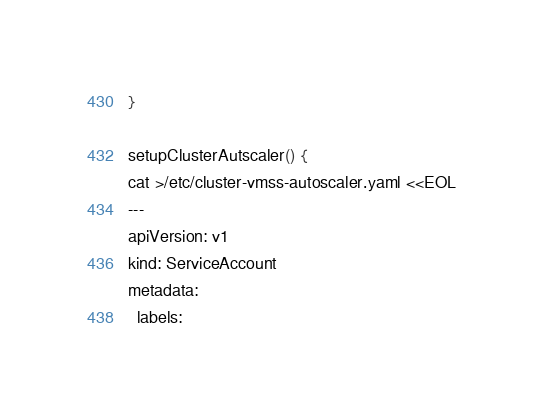<code> <loc_0><loc_0><loc_500><loc_500><_Bash_>}

setupClusterAutscaler() {
cat >/etc/cluster-vmss-autoscaler.yaml <<EOL
---
apiVersion: v1
kind: ServiceAccount
metadata:
  labels:</code> 